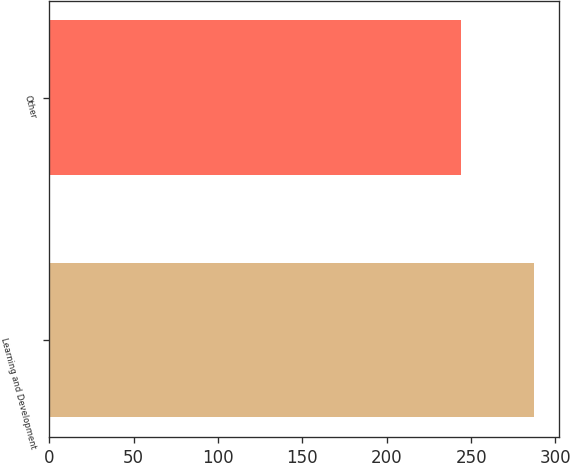Convert chart. <chart><loc_0><loc_0><loc_500><loc_500><bar_chart><fcel>Learning and Development<fcel>Other<nl><fcel>287.5<fcel>244.2<nl></chart> 